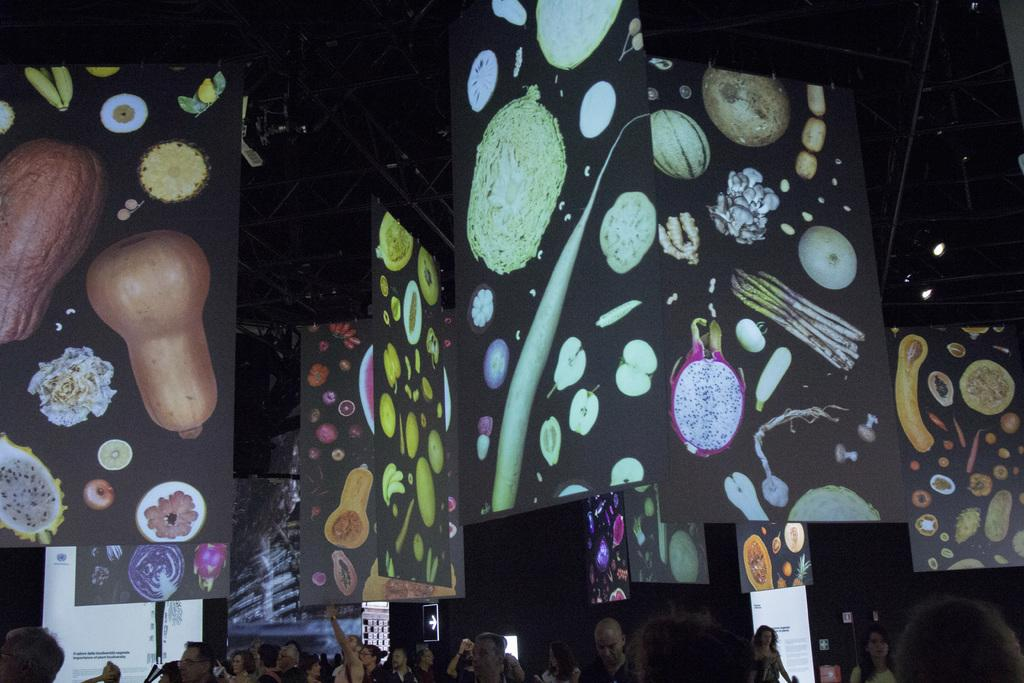Who or what is present in the image? There are people in the image. What objects can be seen in the image? There are boards in the image. What can be observed about the background of the image? The background of the image is dark. What type of soup is being served by the giants in the image? There are no giants or soup present in the image. How many balls are visible in the image? There are no balls visible in the image. 